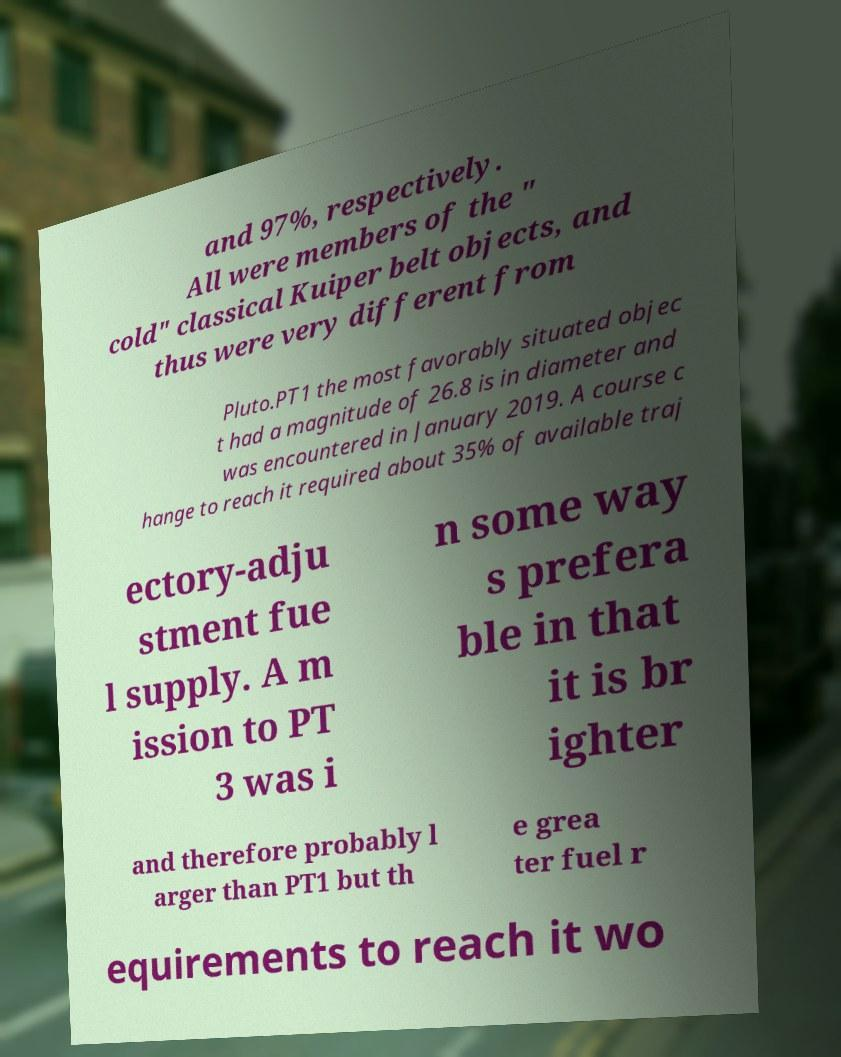Can you accurately transcribe the text from the provided image for me? and 97%, respectively. All were members of the " cold" classical Kuiper belt objects, and thus were very different from Pluto.PT1 the most favorably situated objec t had a magnitude of 26.8 is in diameter and was encountered in January 2019. A course c hange to reach it required about 35% of available traj ectory-adju stment fue l supply. A m ission to PT 3 was i n some way s prefera ble in that it is br ighter and therefore probably l arger than PT1 but th e grea ter fuel r equirements to reach it wo 